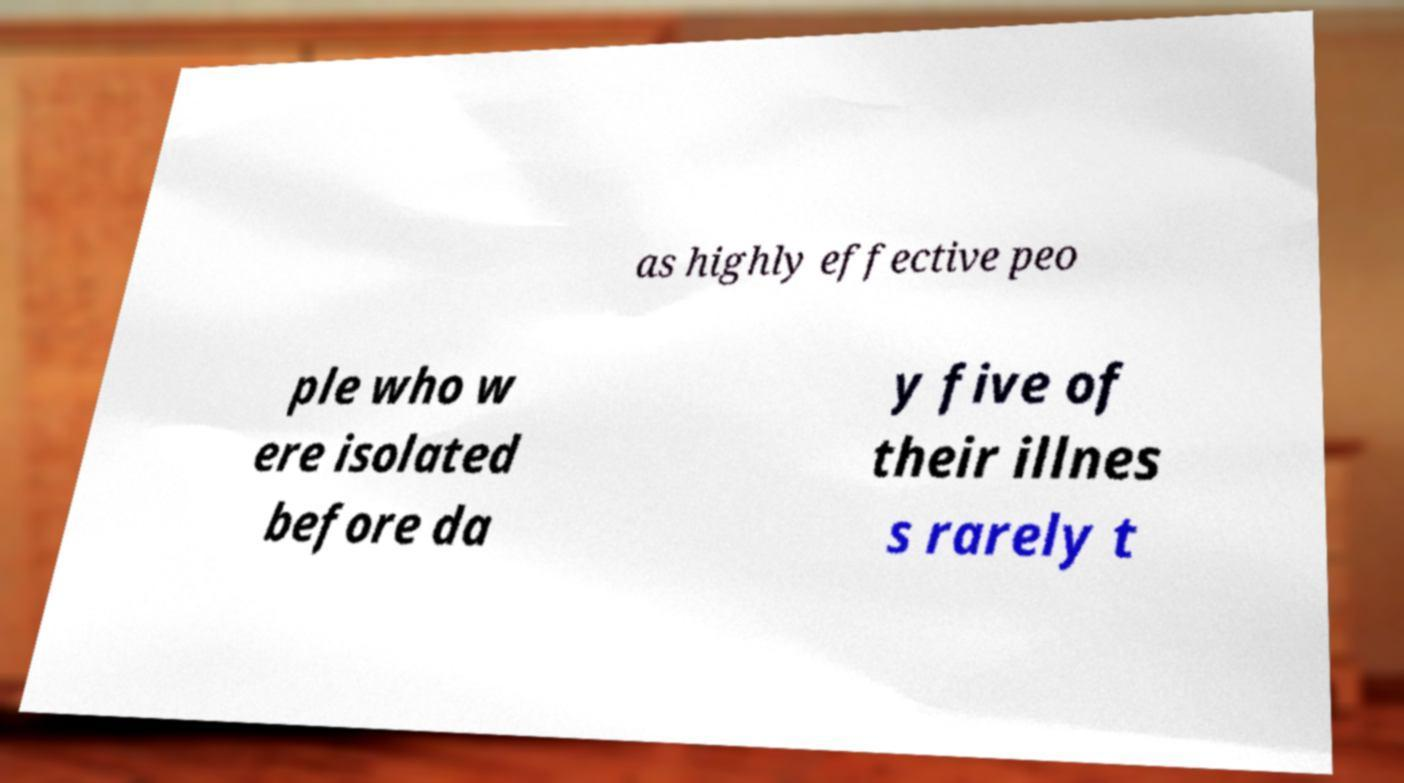What messages or text are displayed in this image? I need them in a readable, typed format. as highly effective peo ple who w ere isolated before da y five of their illnes s rarely t 